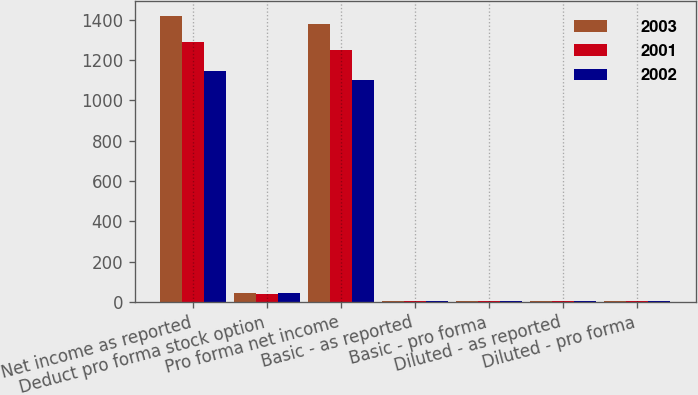Convert chart. <chart><loc_0><loc_0><loc_500><loc_500><stacked_bar_chart><ecel><fcel>Net income as reported<fcel>Deduct pro forma stock option<fcel>Pro forma net income<fcel>Basic - as reported<fcel>Basic - pro forma<fcel>Diluted - as reported<fcel>Diluted - pro forma<nl><fcel>2003<fcel>1421.3<fcel>44.2<fcel>1377.1<fcel>2.6<fcel>2.52<fcel>2.46<fcel>2.38<nl><fcel>2001<fcel>1288.3<fcel>39.5<fcel>1248.8<fcel>2.33<fcel>2.26<fcel>2.19<fcel>2.12<nl><fcel>2002<fcel>1146.6<fcel>44.9<fcel>1101.7<fcel>2.02<fcel>1.94<fcel>1.89<fcel>1.81<nl></chart> 